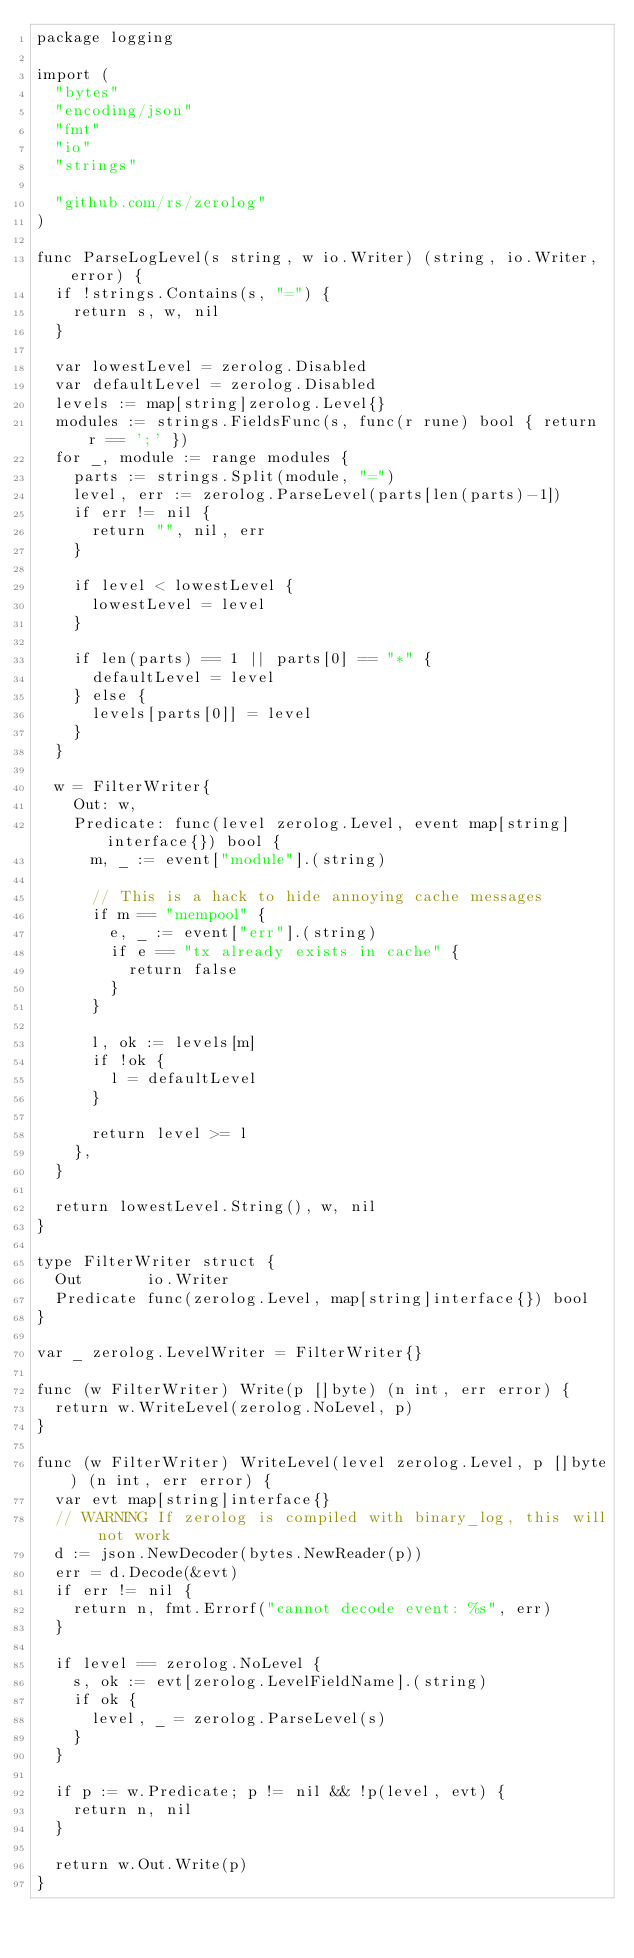<code> <loc_0><loc_0><loc_500><loc_500><_Go_>package logging

import (
	"bytes"
	"encoding/json"
	"fmt"
	"io"
	"strings"

	"github.com/rs/zerolog"
)

func ParseLogLevel(s string, w io.Writer) (string, io.Writer, error) {
	if !strings.Contains(s, "=") {
		return s, w, nil
	}

	var lowestLevel = zerolog.Disabled
	var defaultLevel = zerolog.Disabled
	levels := map[string]zerolog.Level{}
	modules := strings.FieldsFunc(s, func(r rune) bool { return r == ';' })
	for _, module := range modules {
		parts := strings.Split(module, "=")
		level, err := zerolog.ParseLevel(parts[len(parts)-1])
		if err != nil {
			return "", nil, err
		}

		if level < lowestLevel {
			lowestLevel = level
		}

		if len(parts) == 1 || parts[0] == "*" {
			defaultLevel = level
		} else {
			levels[parts[0]] = level
		}
	}

	w = FilterWriter{
		Out: w,
		Predicate: func(level zerolog.Level, event map[string]interface{}) bool {
			m, _ := event["module"].(string)

			// This is a hack to hide annoying cache messages
			if m == "mempool" {
				e, _ := event["err"].(string)
				if e == "tx already exists in cache" {
					return false
				}
			}

			l, ok := levels[m]
			if !ok {
				l = defaultLevel
			}

			return level >= l
		},
	}

	return lowestLevel.String(), w, nil
}

type FilterWriter struct {
	Out       io.Writer
	Predicate func(zerolog.Level, map[string]interface{}) bool
}

var _ zerolog.LevelWriter = FilterWriter{}

func (w FilterWriter) Write(p []byte) (n int, err error) {
	return w.WriteLevel(zerolog.NoLevel, p)
}

func (w FilterWriter) WriteLevel(level zerolog.Level, p []byte) (n int, err error) {
	var evt map[string]interface{}
	// WARNING If zerolog is compiled with binary_log, this will not work
	d := json.NewDecoder(bytes.NewReader(p))
	err = d.Decode(&evt)
	if err != nil {
		return n, fmt.Errorf("cannot decode event: %s", err)
	}

	if level == zerolog.NoLevel {
		s, ok := evt[zerolog.LevelFieldName].(string)
		if ok {
			level, _ = zerolog.ParseLevel(s)
		}
	}

	if p := w.Predicate; p != nil && !p(level, evt) {
		return n, nil
	}

	return w.Out.Write(p)
}
</code> 